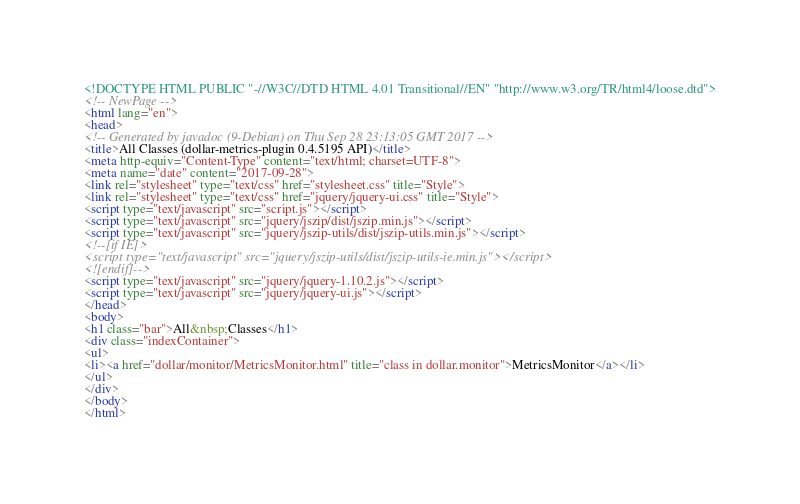<code> <loc_0><loc_0><loc_500><loc_500><_HTML_><!DOCTYPE HTML PUBLIC "-//W3C//DTD HTML 4.01 Transitional//EN" "http://www.w3.org/TR/html4/loose.dtd">
<!-- NewPage -->
<html lang="en">
<head>
<!-- Generated by javadoc (9-Debian) on Thu Sep 28 23:13:05 GMT 2017 -->
<title>All Classes (dollar-metrics-plugin 0.4.5195 API)</title>
<meta http-equiv="Content-Type" content="text/html; charset=UTF-8">
<meta name="date" content="2017-09-28">
<link rel="stylesheet" type="text/css" href="stylesheet.css" title="Style">
<link rel="stylesheet" type="text/css" href="jquery/jquery-ui.css" title="Style">
<script type="text/javascript" src="script.js"></script>
<script type="text/javascript" src="jquery/jszip/dist/jszip.min.js"></script>
<script type="text/javascript" src="jquery/jszip-utils/dist/jszip-utils.min.js"></script>
<!--[if IE]>
<script type="text/javascript" src="jquery/jszip-utils/dist/jszip-utils-ie.min.js"></script>
<![endif]-->
<script type="text/javascript" src="jquery/jquery-1.10.2.js"></script>
<script type="text/javascript" src="jquery/jquery-ui.js"></script>
</head>
<body>
<h1 class="bar">All&nbsp;Classes</h1>
<div class="indexContainer">
<ul>
<li><a href="dollar/monitor/MetricsMonitor.html" title="class in dollar.monitor">MetricsMonitor</a></li>
</ul>
</div>
</body>
</html>
</code> 